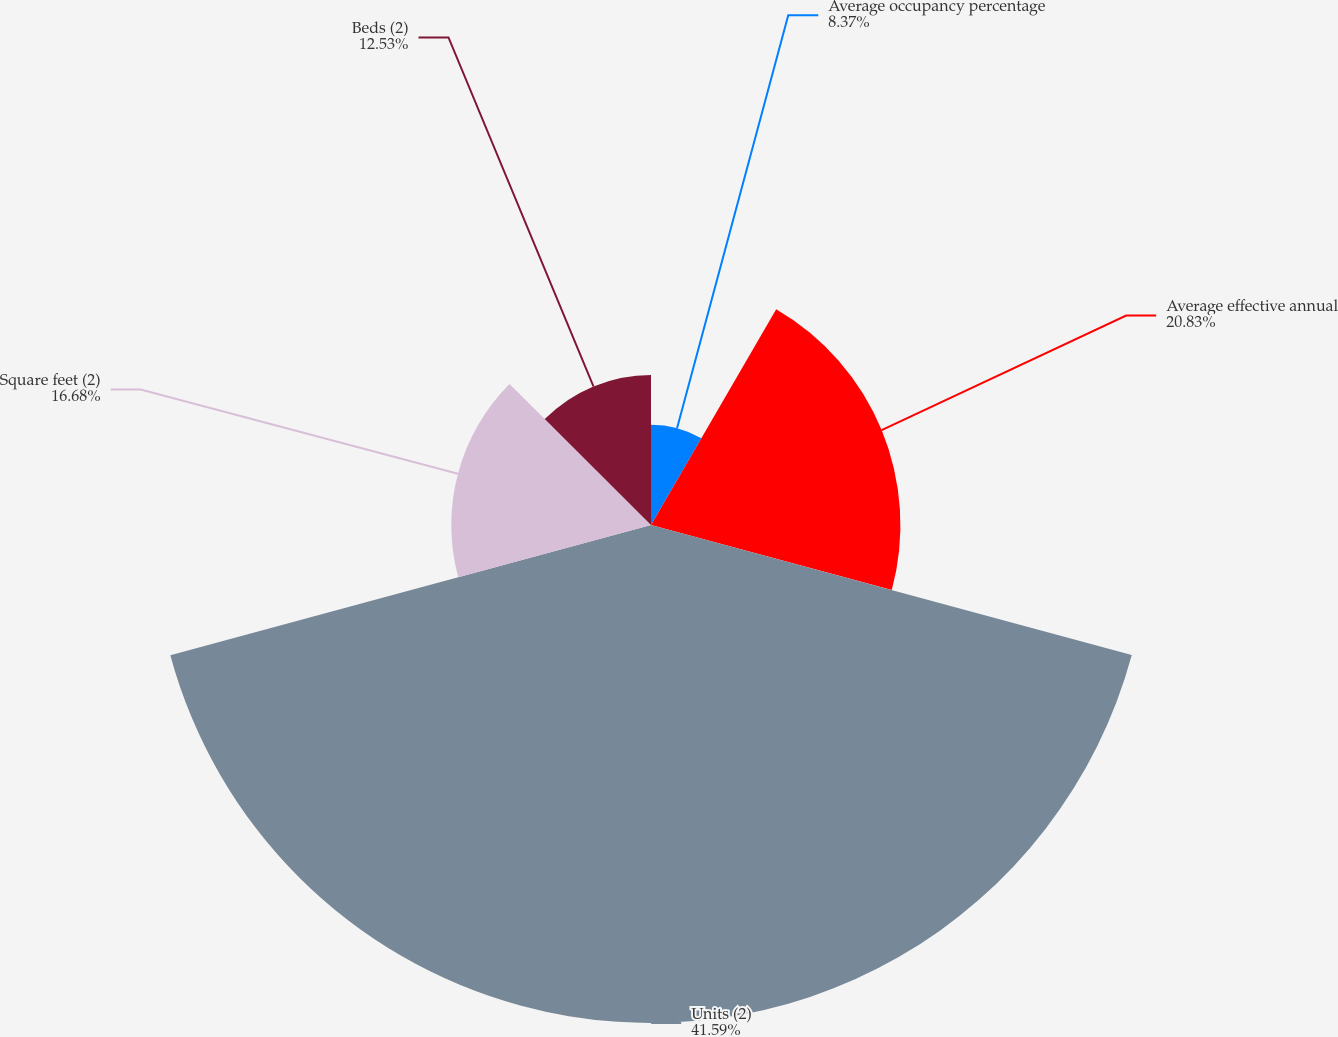<chart> <loc_0><loc_0><loc_500><loc_500><pie_chart><fcel>Average occupancy percentage<fcel>Average effective annual<fcel>Units (2)<fcel>Square feet (2)<fcel>Beds (2)<nl><fcel>8.37%<fcel>20.83%<fcel>41.59%<fcel>16.68%<fcel>12.53%<nl></chart> 